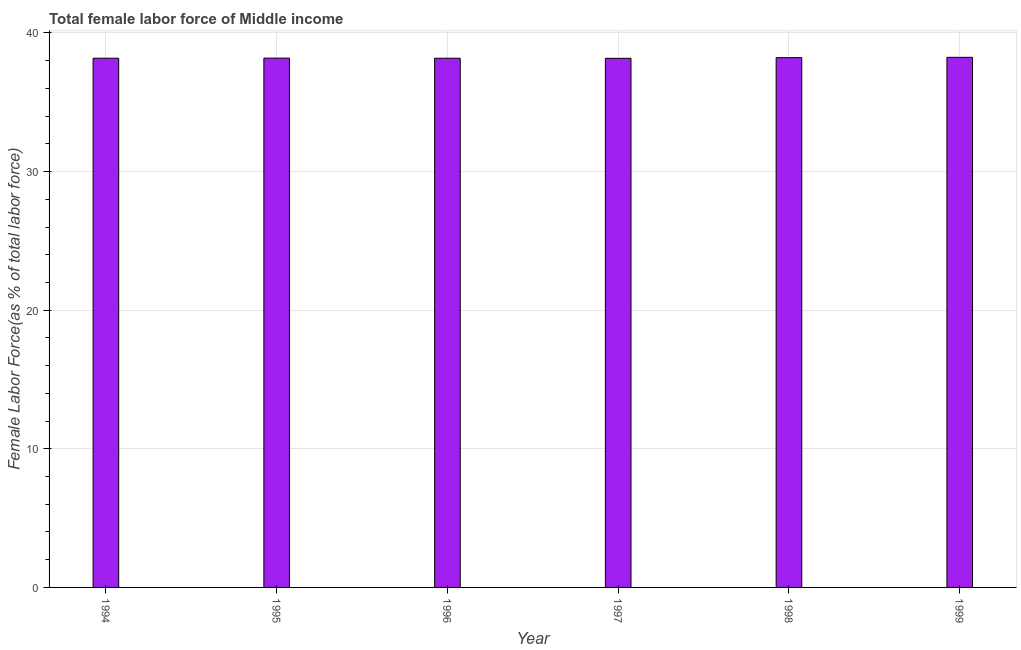Does the graph contain any zero values?
Keep it short and to the point. No. Does the graph contain grids?
Offer a very short reply. Yes. What is the title of the graph?
Provide a succinct answer. Total female labor force of Middle income. What is the label or title of the Y-axis?
Provide a short and direct response. Female Labor Force(as % of total labor force). What is the total female labor force in 1996?
Provide a succinct answer. 38.18. Across all years, what is the maximum total female labor force?
Offer a very short reply. 38.24. Across all years, what is the minimum total female labor force?
Offer a very short reply. 38.17. In which year was the total female labor force maximum?
Your response must be concise. 1999. In which year was the total female labor force minimum?
Offer a terse response. 1997. What is the sum of the total female labor force?
Provide a succinct answer. 229.16. What is the difference between the total female labor force in 1998 and 1999?
Keep it short and to the point. -0.02. What is the average total female labor force per year?
Offer a very short reply. 38.19. What is the median total female labor force?
Your answer should be very brief. 38.18. Do a majority of the years between 1998 and 1997 (inclusive) have total female labor force greater than 34 %?
Give a very brief answer. No. Is the total female labor force in 1998 less than that in 1999?
Provide a short and direct response. Yes. Is the difference between the total female labor force in 1994 and 1997 greater than the difference between any two years?
Make the answer very short. No. What is the difference between the highest and the second highest total female labor force?
Offer a very short reply. 0.02. Is the sum of the total female labor force in 1995 and 1996 greater than the maximum total female labor force across all years?
Your answer should be very brief. Yes. What is the difference between the highest and the lowest total female labor force?
Provide a short and direct response. 0.07. How many bars are there?
Offer a very short reply. 6. How many years are there in the graph?
Provide a short and direct response. 6. Are the values on the major ticks of Y-axis written in scientific E-notation?
Offer a terse response. No. What is the Female Labor Force(as % of total labor force) of 1994?
Make the answer very short. 38.18. What is the Female Labor Force(as % of total labor force) of 1995?
Your answer should be compact. 38.18. What is the Female Labor Force(as % of total labor force) of 1996?
Keep it short and to the point. 38.18. What is the Female Labor Force(as % of total labor force) of 1997?
Make the answer very short. 38.17. What is the Female Labor Force(as % of total labor force) in 1998?
Your answer should be very brief. 38.22. What is the Female Labor Force(as % of total labor force) in 1999?
Your answer should be compact. 38.24. What is the difference between the Female Labor Force(as % of total labor force) in 1994 and 1995?
Keep it short and to the point. -0.01. What is the difference between the Female Labor Force(as % of total labor force) in 1994 and 1996?
Your answer should be very brief. 0. What is the difference between the Female Labor Force(as % of total labor force) in 1994 and 1997?
Your response must be concise. 0.01. What is the difference between the Female Labor Force(as % of total labor force) in 1994 and 1998?
Ensure brevity in your answer.  -0.04. What is the difference between the Female Labor Force(as % of total labor force) in 1994 and 1999?
Your answer should be very brief. -0.06. What is the difference between the Female Labor Force(as % of total labor force) in 1995 and 1996?
Ensure brevity in your answer.  0.01. What is the difference between the Female Labor Force(as % of total labor force) in 1995 and 1997?
Ensure brevity in your answer.  0.02. What is the difference between the Female Labor Force(as % of total labor force) in 1995 and 1998?
Make the answer very short. -0.03. What is the difference between the Female Labor Force(as % of total labor force) in 1995 and 1999?
Give a very brief answer. -0.06. What is the difference between the Female Labor Force(as % of total labor force) in 1996 and 1997?
Ensure brevity in your answer.  0.01. What is the difference between the Female Labor Force(as % of total labor force) in 1996 and 1998?
Offer a terse response. -0.04. What is the difference between the Female Labor Force(as % of total labor force) in 1996 and 1999?
Give a very brief answer. -0.06. What is the difference between the Female Labor Force(as % of total labor force) in 1997 and 1998?
Provide a succinct answer. -0.05. What is the difference between the Female Labor Force(as % of total labor force) in 1997 and 1999?
Keep it short and to the point. -0.07. What is the difference between the Female Labor Force(as % of total labor force) in 1998 and 1999?
Give a very brief answer. -0.02. What is the ratio of the Female Labor Force(as % of total labor force) in 1994 to that in 1996?
Your response must be concise. 1. What is the ratio of the Female Labor Force(as % of total labor force) in 1994 to that in 1997?
Provide a short and direct response. 1. What is the ratio of the Female Labor Force(as % of total labor force) in 1994 to that in 1998?
Provide a succinct answer. 1. What is the ratio of the Female Labor Force(as % of total labor force) in 1995 to that in 1998?
Offer a very short reply. 1. What is the ratio of the Female Labor Force(as % of total labor force) in 1996 to that in 1997?
Provide a succinct answer. 1. What is the ratio of the Female Labor Force(as % of total labor force) in 1996 to that in 1998?
Provide a succinct answer. 1. What is the ratio of the Female Labor Force(as % of total labor force) in 1996 to that in 1999?
Your answer should be compact. 1. 